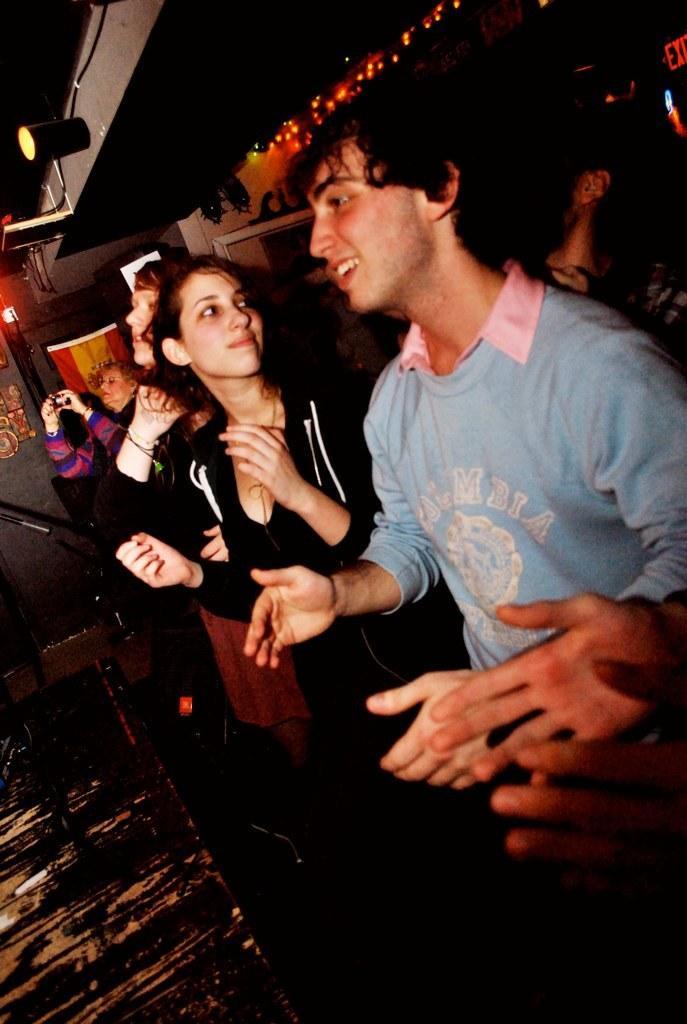Please provide a concise description of this image. This image consists of many people. In the front, we can see a boy wearing a blue T-shirt and a girl wearing a black jacket. It looks like a pub. At the top, we can see a lamp. 